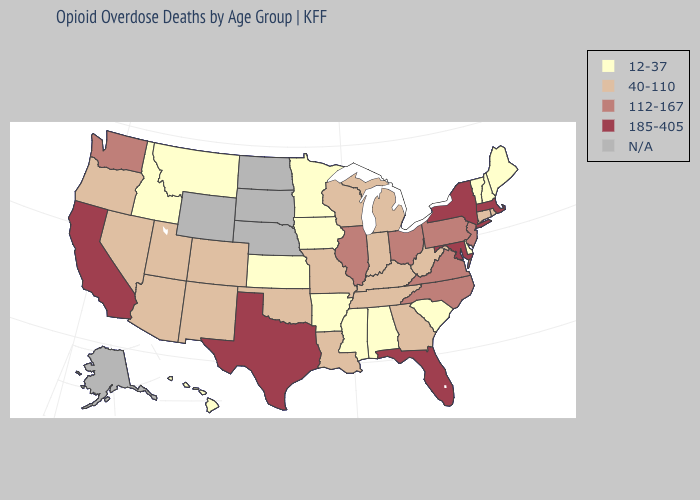Which states have the lowest value in the USA?
Keep it brief. Alabama, Arkansas, Delaware, Hawaii, Idaho, Iowa, Kansas, Maine, Minnesota, Mississippi, Montana, New Hampshire, South Carolina, Vermont. Which states hav the highest value in the Northeast?
Write a very short answer. Massachusetts, New York. Which states have the highest value in the USA?
Give a very brief answer. California, Florida, Maryland, Massachusetts, New York, Texas. What is the lowest value in the USA?
Short answer required. 12-37. What is the lowest value in states that border North Dakota?
Write a very short answer. 12-37. What is the value of New Jersey?
Give a very brief answer. 112-167. Name the states that have a value in the range 185-405?
Short answer required. California, Florida, Maryland, Massachusetts, New York, Texas. Name the states that have a value in the range N/A?
Short answer required. Alaska, Nebraska, North Dakota, South Dakota, Wyoming. Which states hav the highest value in the MidWest?
Write a very short answer. Illinois, Ohio. Which states have the lowest value in the USA?
Give a very brief answer. Alabama, Arkansas, Delaware, Hawaii, Idaho, Iowa, Kansas, Maine, Minnesota, Mississippi, Montana, New Hampshire, South Carolina, Vermont. Name the states that have a value in the range N/A?
Write a very short answer. Alaska, Nebraska, North Dakota, South Dakota, Wyoming. Does Vermont have the lowest value in the Northeast?
Keep it brief. Yes. Among the states that border Iowa , which have the lowest value?
Write a very short answer. Minnesota. Name the states that have a value in the range 40-110?
Concise answer only. Arizona, Colorado, Connecticut, Georgia, Indiana, Kentucky, Louisiana, Michigan, Missouri, Nevada, New Mexico, Oklahoma, Oregon, Rhode Island, Tennessee, Utah, West Virginia, Wisconsin. 